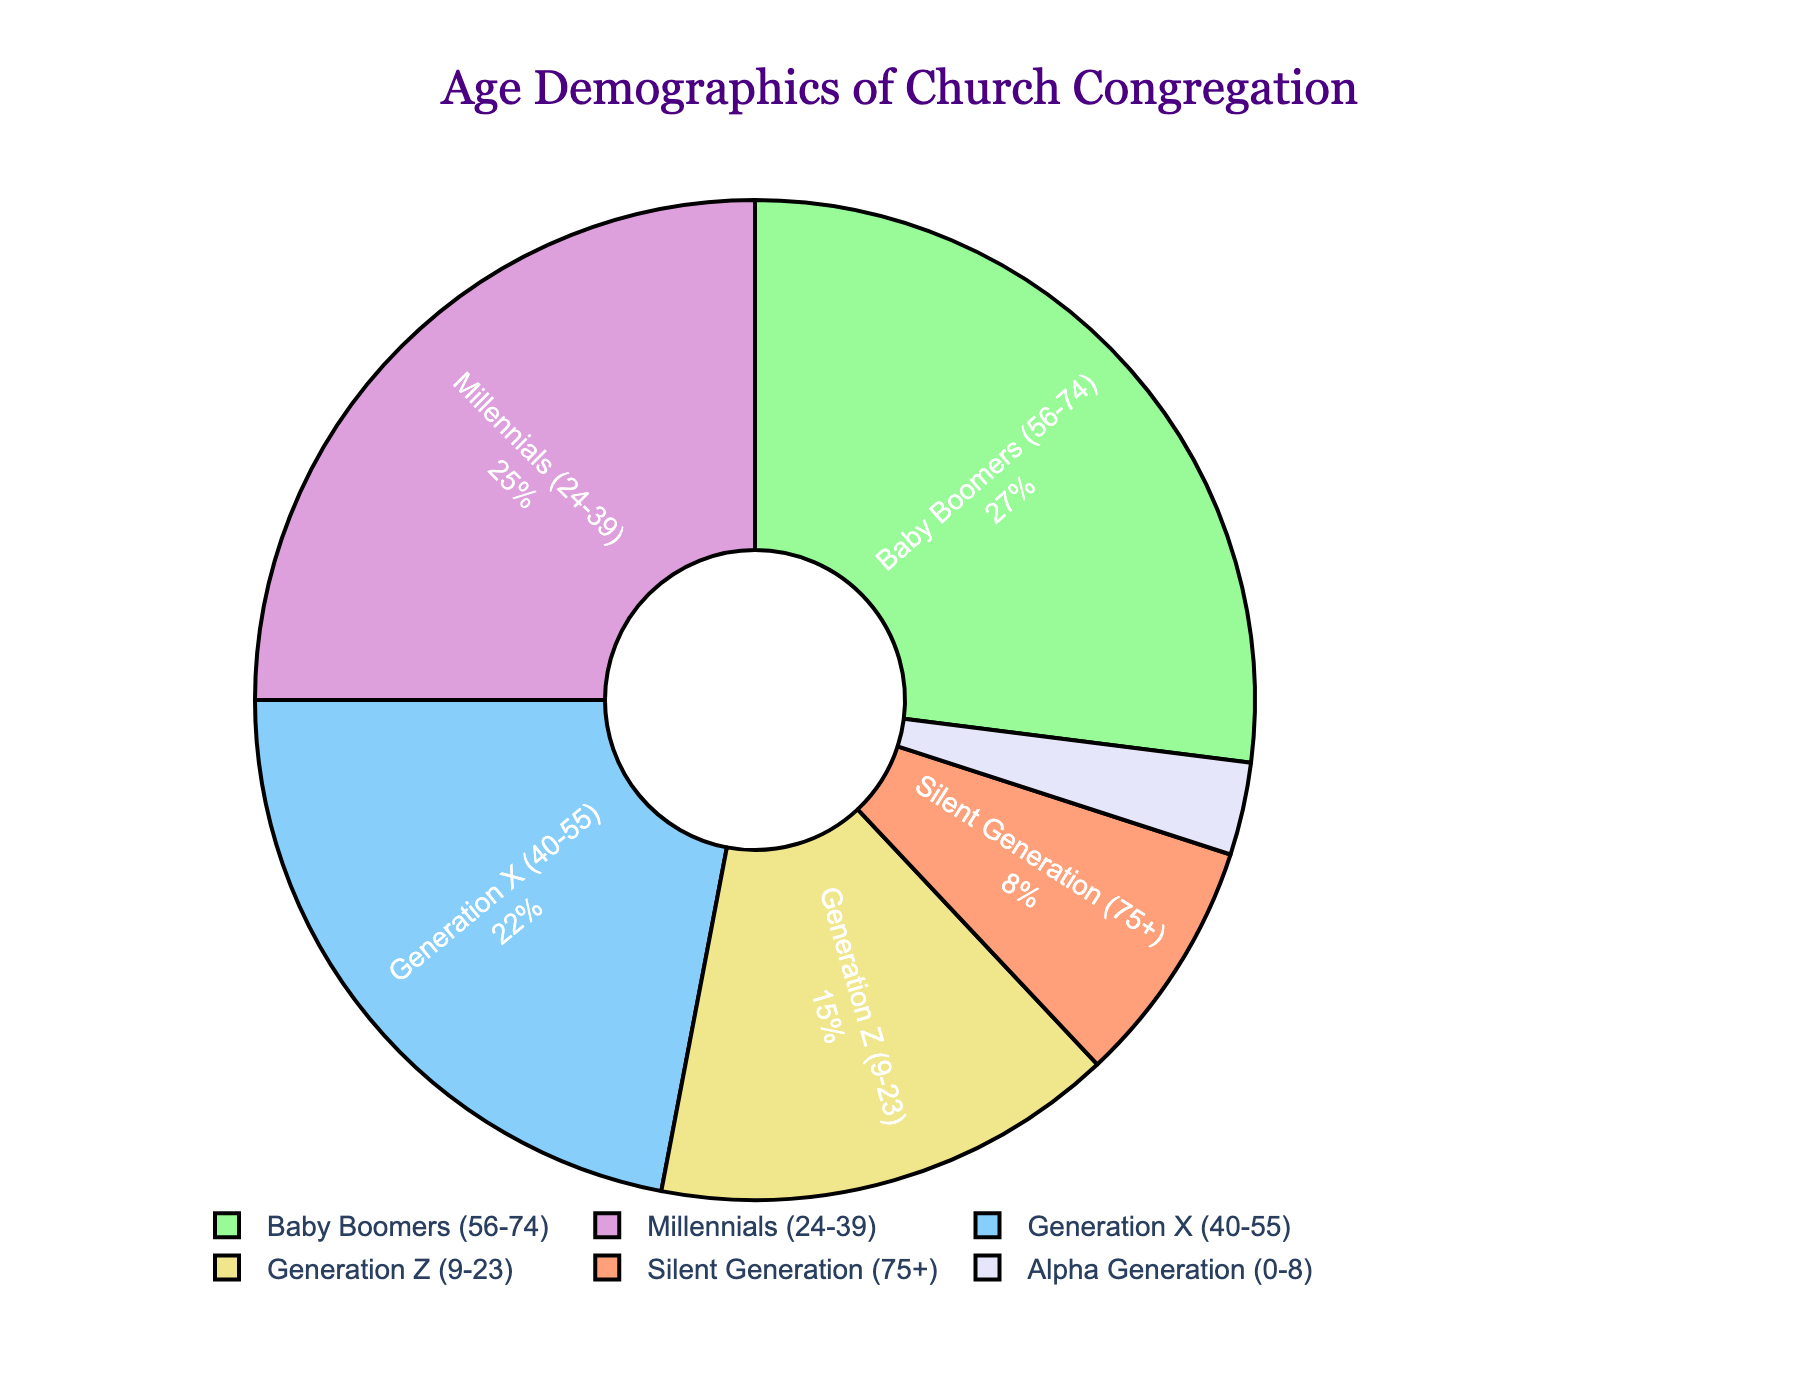Which generation has the highest percentage of the church congregation? By looking at the pie chart, it's clear that the Baby Boomers segment, which is larger compared to the other segments, has the highest percentage.
Answer: Baby Boomers What percentage of the congregation is made up by Millennials and Generation Z combined? First, find the individual percentages of Millennials (25%) and Generation Z (15%), then add them together. 25% + 15% = 40%.
Answer: 40% Which generation has a smaller percentage than Generation Z but larger than Alpha Generation? By referring to the percentages on the pie chart, after identifying that Generation Z is 15% and Alpha Generation is 3%, we see that the Silent Generation at 8% fits this criterion.
Answer: Silent Generation Is the percentage of Baby Boomers greater than the combined percentage of Silent Generation and Alpha Generation? First, sum the percentages of Silent Generation (8%) and Alpha Generation (3%), which is 11%. Then, compare it to Baby Boomers' percentage, which is 27%. Since 27% is greater than 11%, the answer is yes.
Answer: Yes What is the difference in percentage between Generation X and Millennials? Subtract the percentage of Millennials (25%) from Generation X (22%). 22% - 25% = -3%. Though the exact difference as a positive value.
Answer: 3% How does the percentage of Generation X compare to Baby Boomers? The percentages from the chart indicate that Baby Boomers have 27%, and Generation X has 22%. So, Baby Boomers have a higher percentage than Generation X.
Answer: Baby Boomers have a higher percentage Which generation is represented by the yellow color in the pie chart? Identifying colors from the pie chart, the yellow segment corresponds to the Millennials.
Answer: Millennials 